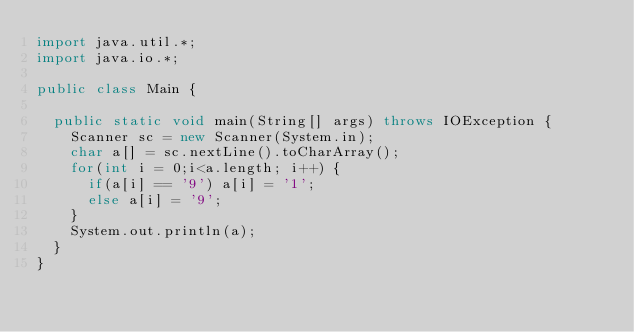<code> <loc_0><loc_0><loc_500><loc_500><_Java_>import java.util.*;
import java.io.*;

public class Main {
	
	public static void main(String[] args) throws IOException {
		Scanner sc = new Scanner(System.in);
		char a[] = sc.nextLine().toCharArray();
		for(int i = 0;i<a.length; i++) {
			if(a[i] == '9') a[i] = '1'; 
			else a[i] = '9';
		}
		System.out.println(a);
	}
}</code> 